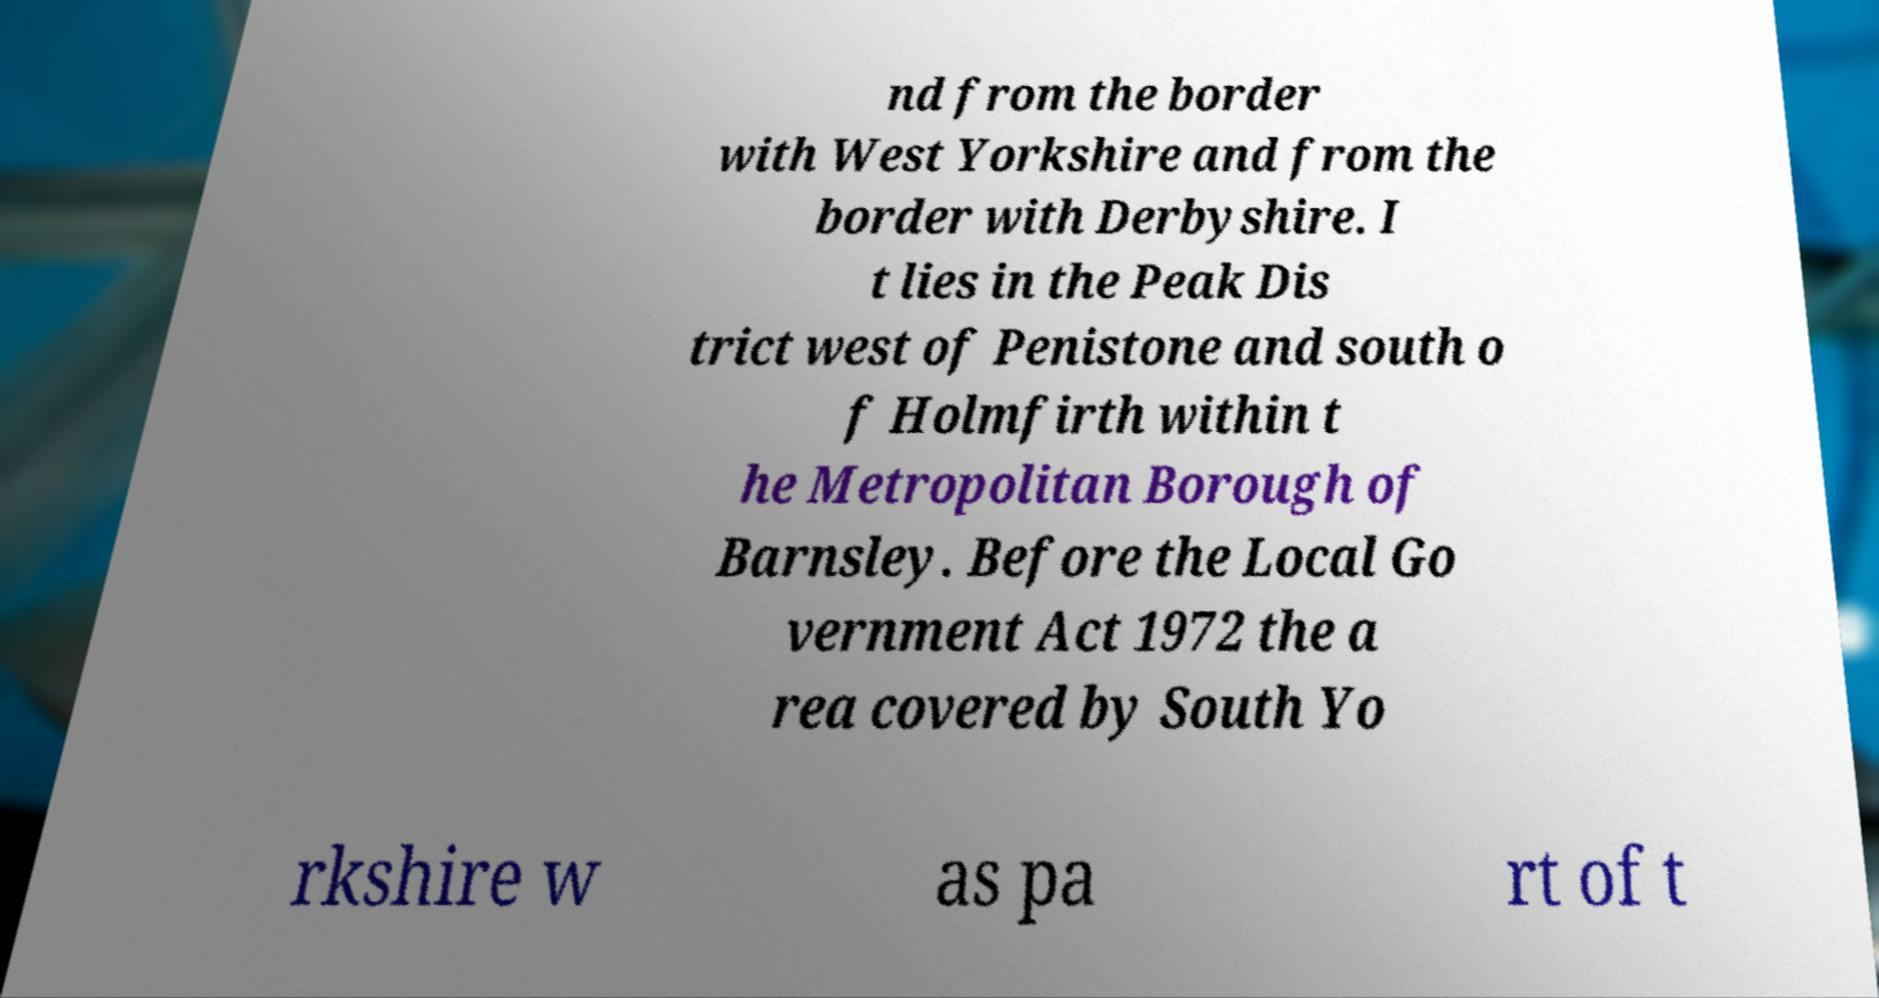Can you accurately transcribe the text from the provided image for me? nd from the border with West Yorkshire and from the border with Derbyshire. I t lies in the Peak Dis trict west of Penistone and south o f Holmfirth within t he Metropolitan Borough of Barnsley. Before the Local Go vernment Act 1972 the a rea covered by South Yo rkshire w as pa rt of t 